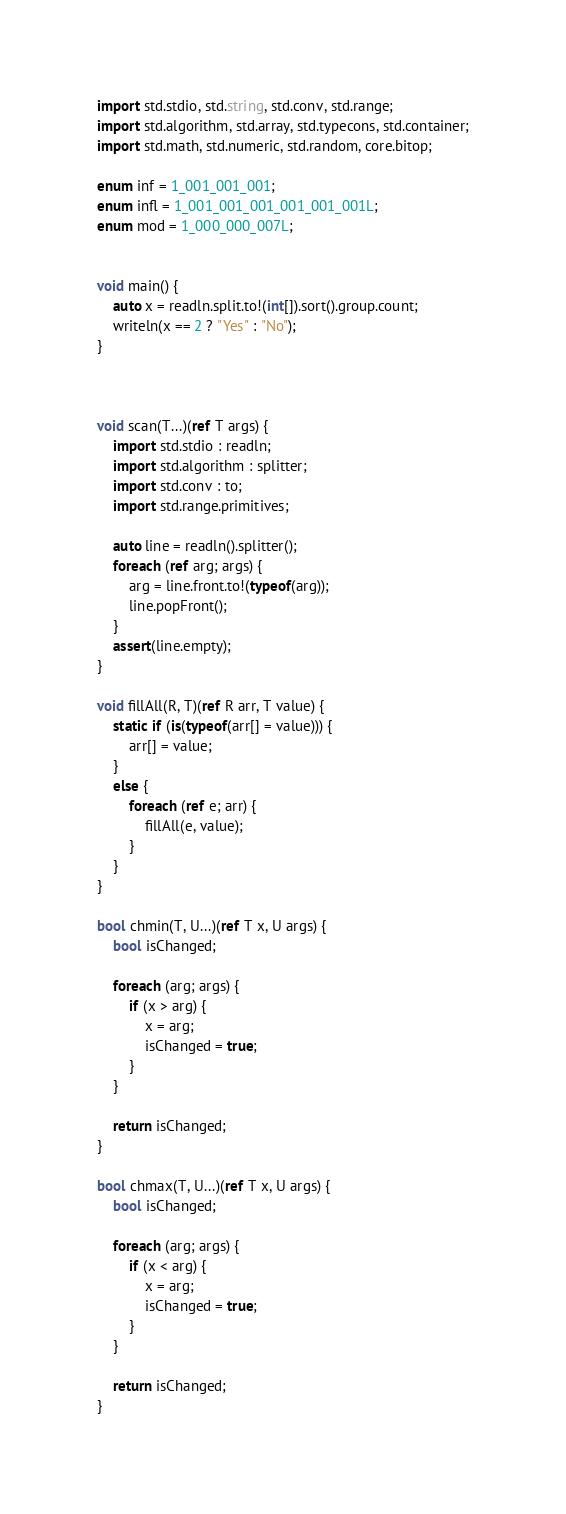Convert code to text. <code><loc_0><loc_0><loc_500><loc_500><_D_>import std.stdio, std.string, std.conv, std.range;
import std.algorithm, std.array, std.typecons, std.container;
import std.math, std.numeric, std.random, core.bitop;

enum inf = 1_001_001_001;
enum infl = 1_001_001_001_001_001_001L;
enum mod = 1_000_000_007L;


void main() {
    auto x = readln.split.to!(int[]).sort().group.count;
    writeln(x == 2 ? "Yes" : "No");
}



void scan(T...)(ref T args) {
    import std.stdio : readln;
    import std.algorithm : splitter;
    import std.conv : to;
    import std.range.primitives;

    auto line = readln().splitter();
    foreach (ref arg; args) {
        arg = line.front.to!(typeof(arg));
        line.popFront();
    }
    assert(line.empty);
}

void fillAll(R, T)(ref R arr, T value) {
    static if (is(typeof(arr[] = value))) {
        arr[] = value;
    }
    else {
        foreach (ref e; arr) {
            fillAll(e, value);
        }
    }
}

bool chmin(T, U...)(ref T x, U args) {
    bool isChanged;

    foreach (arg; args) {
        if (x > arg) {
            x = arg;
            isChanged = true;
        }
    }

    return isChanged;
}

bool chmax(T, U...)(ref T x, U args) {
    bool isChanged;

    foreach (arg; args) {
        if (x < arg) {
            x = arg;
            isChanged = true;
        }
    }

    return isChanged;
}
</code> 